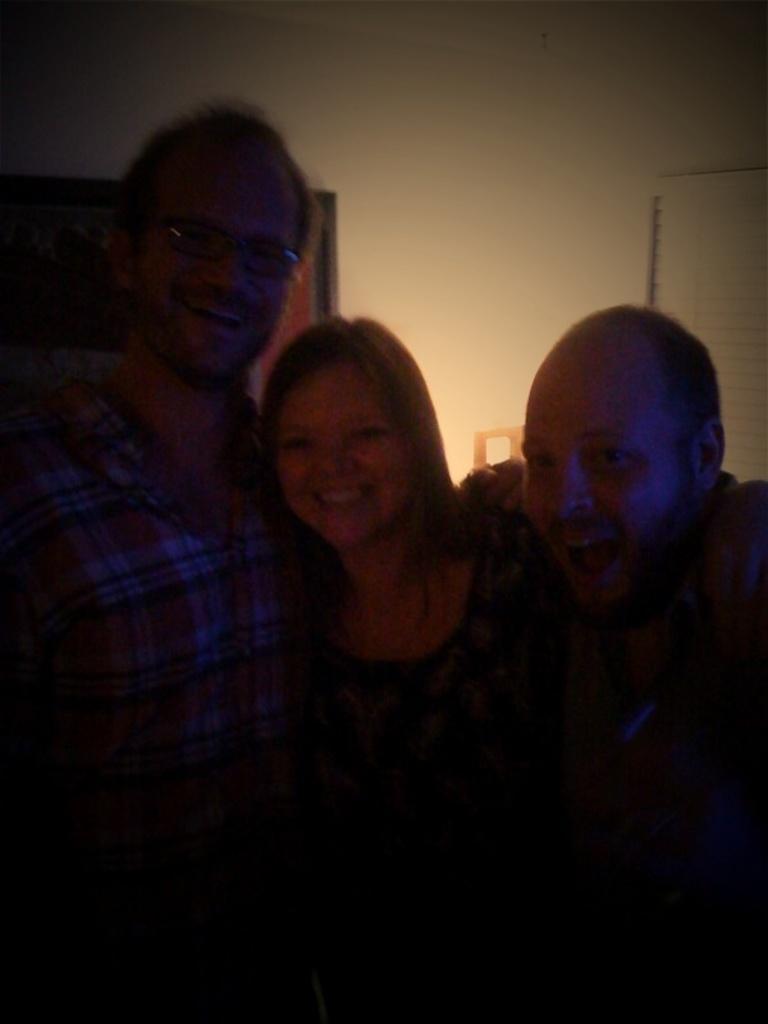Could you give a brief overview of what you see in this image? In this image there are three people posing for the camera with a smile on their face, behind them there is a wall. 